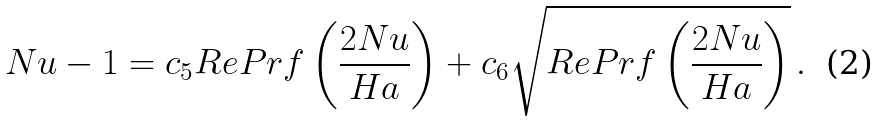<formula> <loc_0><loc_0><loc_500><loc_500>N u - 1 & = c _ { 5 } R e P r f \left ( \frac { 2 N u } { H a } \right ) + c _ { 6 } \sqrt { R e P r f \left ( \frac { 2 N u } { H a } \right ) } \, .</formula> 